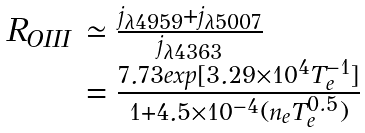<formula> <loc_0><loc_0><loc_500><loc_500>\begin{array} { l l } R _ { O I I I } & \simeq \frac { j _ { \lambda 4 9 5 9 } + j _ { \lambda 5 0 0 7 } } { j _ { \lambda 4 3 6 3 } } \\ & = \frac { 7 . 7 3 e x p [ 3 . 2 9 \times 1 0 ^ { 4 } T _ { e } ^ { - 1 } ] } { 1 + 4 . 5 \times 1 0 ^ { - 4 } ( n _ { e } T _ { e } ^ { 0 . 5 } ) } \end{array}</formula> 